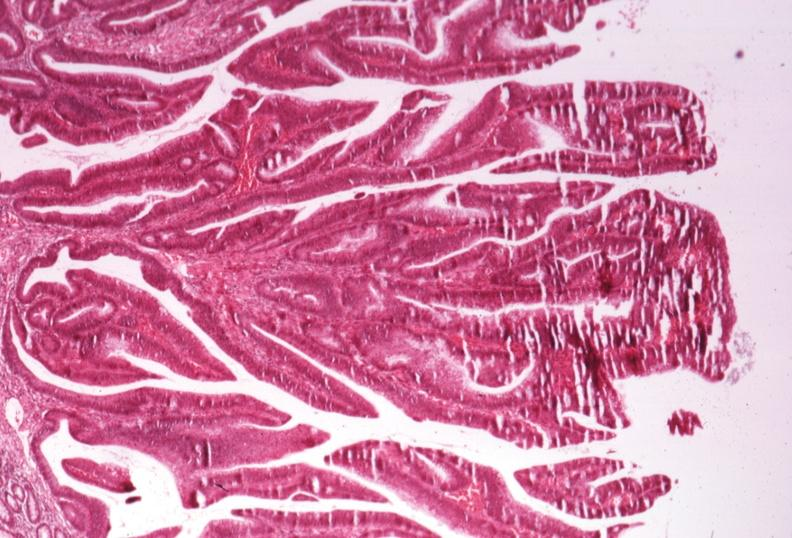s gastrointestinal present?
Answer the question using a single word or phrase. Yes 